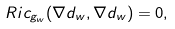Convert formula to latex. <formula><loc_0><loc_0><loc_500><loc_500>R i c _ { g _ { w } } ( \nabla d _ { w } , \nabla d _ { w } ) = 0 ,</formula> 